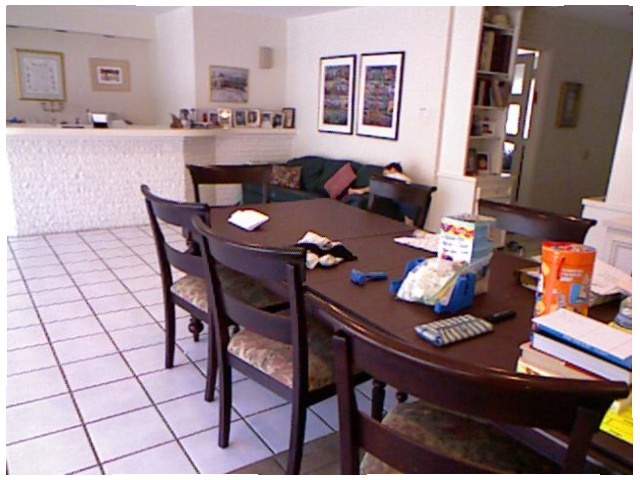<image>
Can you confirm if the chair is under the table? Yes. The chair is positioned underneath the table, with the table above it in the vertical space. Is the chair in front of the table? Yes. The chair is positioned in front of the table, appearing closer to the camera viewpoint. Is the table on the chair? No. The table is not positioned on the chair. They may be near each other, but the table is not supported by or resting on top of the chair. Where is the frame in relation to the books? Is it behind the books? No. The frame is not behind the books. From this viewpoint, the frame appears to be positioned elsewhere in the scene. 